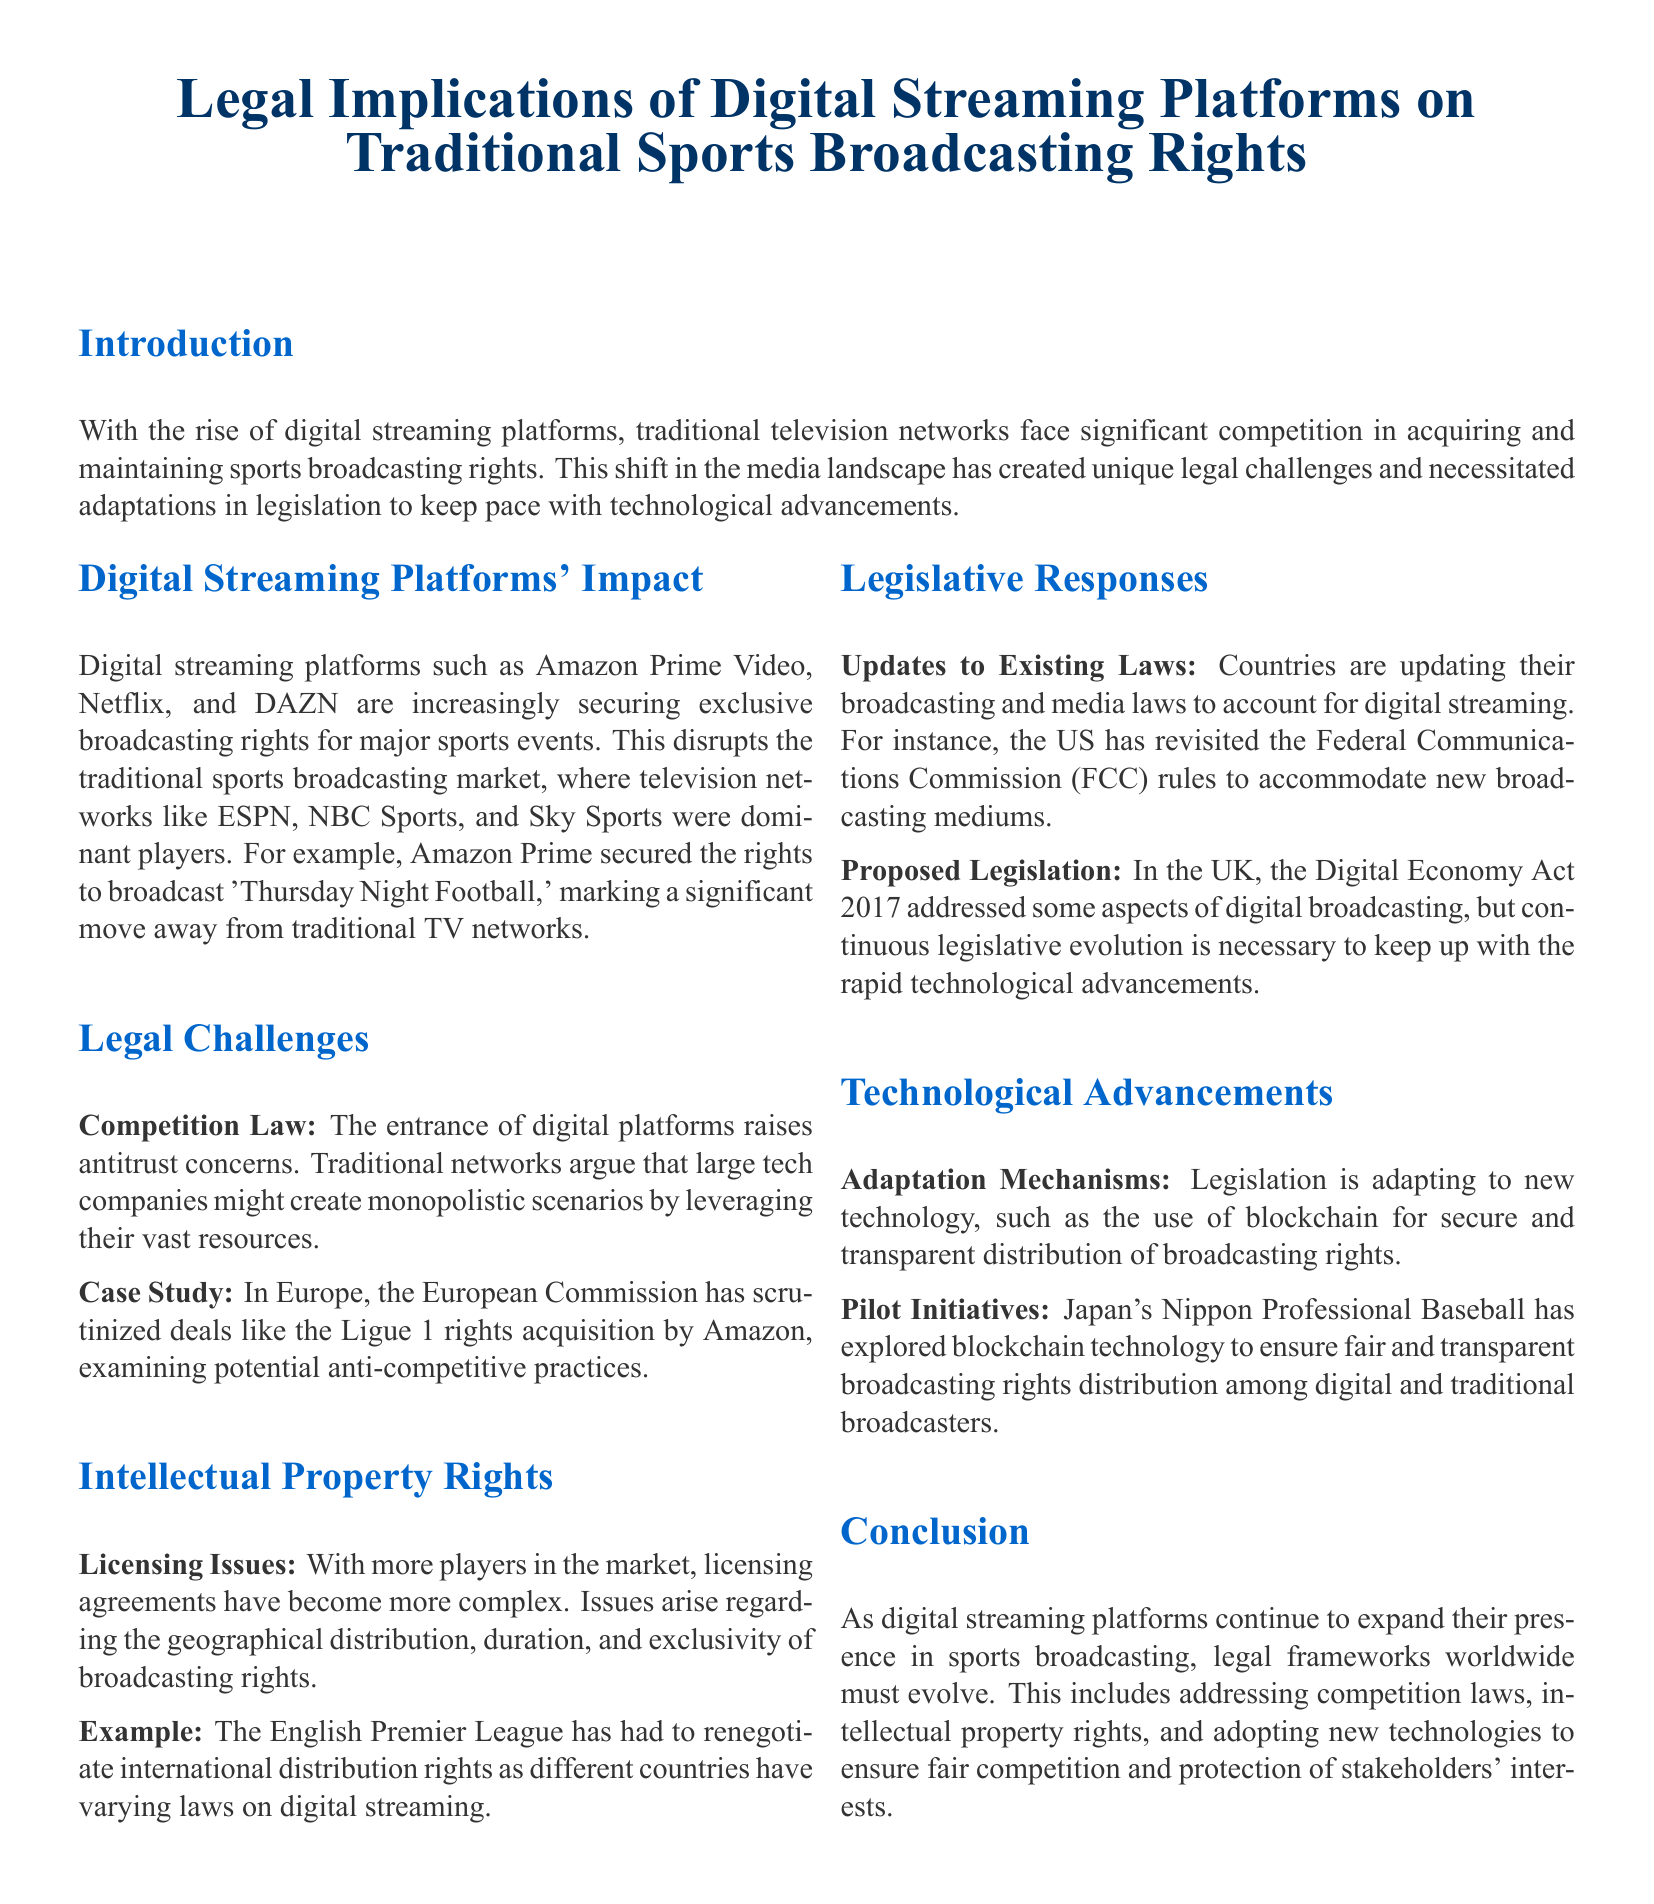What is the title of the document? The title of the document is prominently displayed at the top and states the main topic of the brief.
Answer: Legal Implications of Digital Streaming Platforms on Traditional Sports Broadcasting Rights Which major sports event's broadcasting rights did Amazon Prime secure? The document provides an example of a specific sports event for which Amazon Prime has acquired broadcasting rights.
Answer: Thursday Night Football What legal concerns are raised by the entrance of digital platforms? The document mentions specific legal concerns related to competition law raised by traditional networks due to the presence of digital platforms.
Answer: Antitrust concerns What did the European Commission scrutinize regarding Amazon? The document references a specific examination conducted by the European Commission related to the activities of Amazon in the sports broadcasting sector.
Answer: Ligue 1 rights acquisition Which act in the UK addressed aspects of digital broadcasting? The document cites specific legislation from the UK that is relevant to digital broadcasting.
Answer: Digital Economy Act 2017 What technology is being explored for broadcasting rights distribution? The document discusses a modern technology that is being investigated to enhance transparency in broadcasting rights distribution.
Answer: Blockchain What is required for the legal frameworks to keep pace with digital streaming? The conclusion of the document specifies an ongoing requirement for legal adaptations in relation to the emergence of digital platforms.
Answer: Continuous legislative evolution What type of licensing issues are mentioned? The document highlights a specific type of complication arising from the expanded presence of digital streaming platforms in the sports broadcasting landscape.
Answer: Geographical distribution, duration, and exclusivity What is a pilot initiative mentioned in the document? The document references a specific instance where a sports organization is testing a new technology related to broadcasting rights.
Answer: Japan's Nippon Professional Baseball has explored blockchain technology 